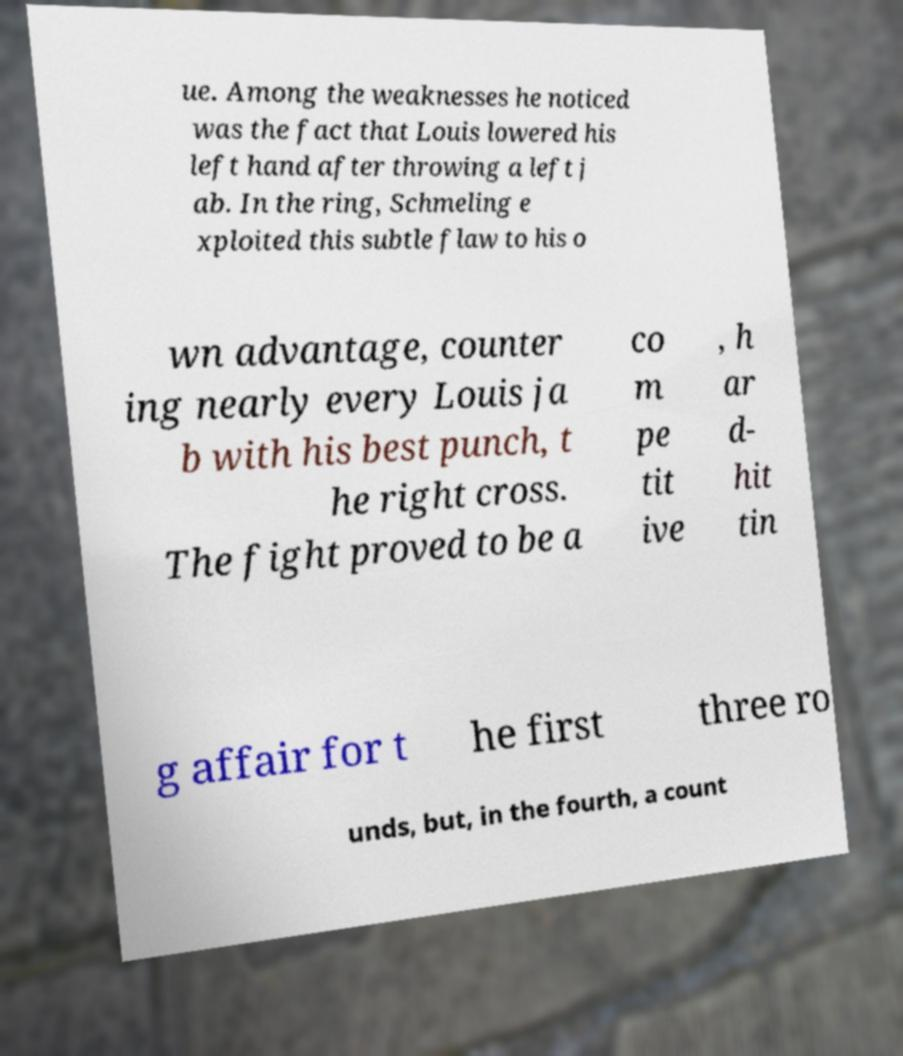Please read and relay the text visible in this image. What does it say? ue. Among the weaknesses he noticed was the fact that Louis lowered his left hand after throwing a left j ab. In the ring, Schmeling e xploited this subtle flaw to his o wn advantage, counter ing nearly every Louis ja b with his best punch, t he right cross. The fight proved to be a co m pe tit ive , h ar d- hit tin g affair for t he first three ro unds, but, in the fourth, a count 